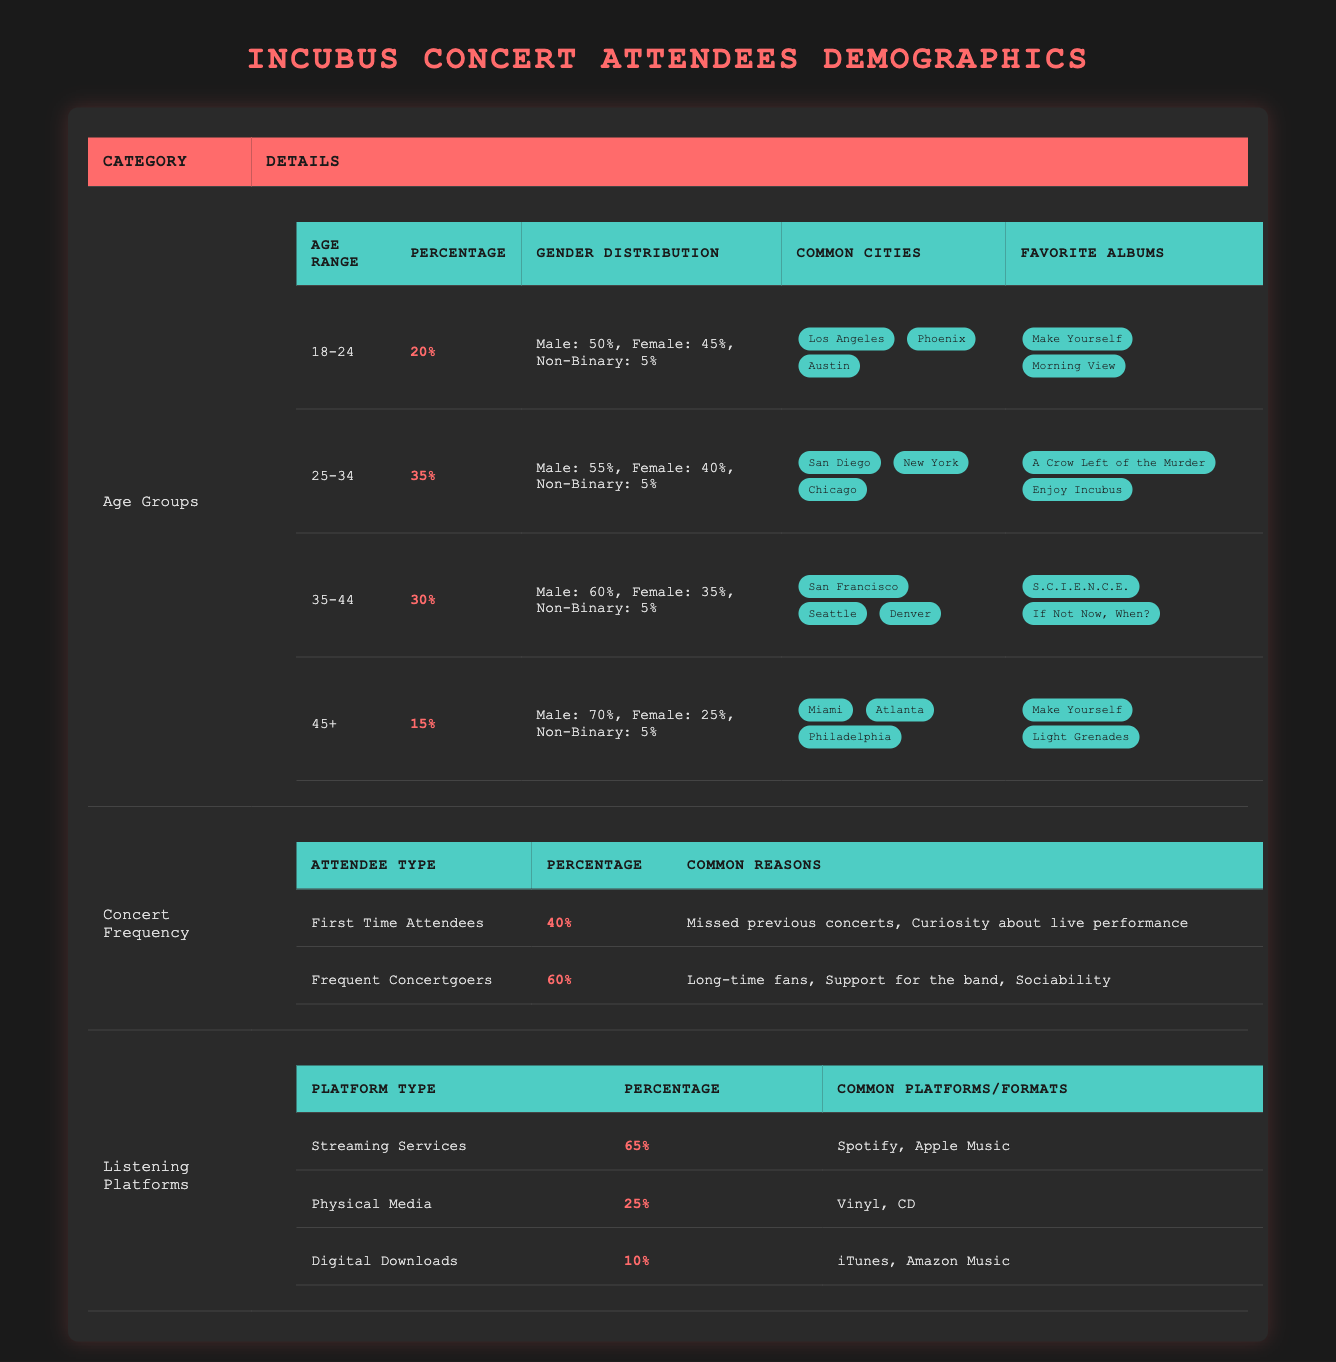What is the percentage of 25-34 year-olds among Incubus concert attendees? The table states that the percentage of the 25-34 age group is 35%.
Answer: 35% Which age group has the highest percentage of attendees? The 25-34 age group has the highest percentage at 35%.
Answer: 25-34 What percentage of attendees listen to music on streaming services? The table shows that 65% of attendees use streaming services to listen to music.
Answer: 65% Is it true that more than half of the concertgoers use physical media? The data indicates that only 25% of attendees use physical media, which is not more than half.
Answer: No What are the common cities for attendees aged 35-44? The table lists San Francisco, Seattle, and Denver as common cities for the 35-44 age group.
Answer: San Francisco, Seattle, Denver How many different platforms do attendees use to listen to Incubus music? Attendees use three types of platforms: streaming services, physical media, and digital downloads.
Answer: Three What is the combined percentage of first-time attendees and frequent concertgoers? The combined percentage is 40% (first-time) + 60% (frequent) = 100%.
Answer: 100% Which age group has the lowest representation of concert attendees? The 45+ age group has the lowest representation at 15%.
Answer: 45+ What is the proportion of non-binary attendees in the 18-24 age group? The non-binary percentage among 18-24 year-olds is 5%, as indicated in the table.
Answer: 5% Do most concertgoers have favorite albums from the Make Yourself era? Yes, both the 18-24 and 45+ age groups list "Make Yourself" as a favorite album.
Answer: Yes 